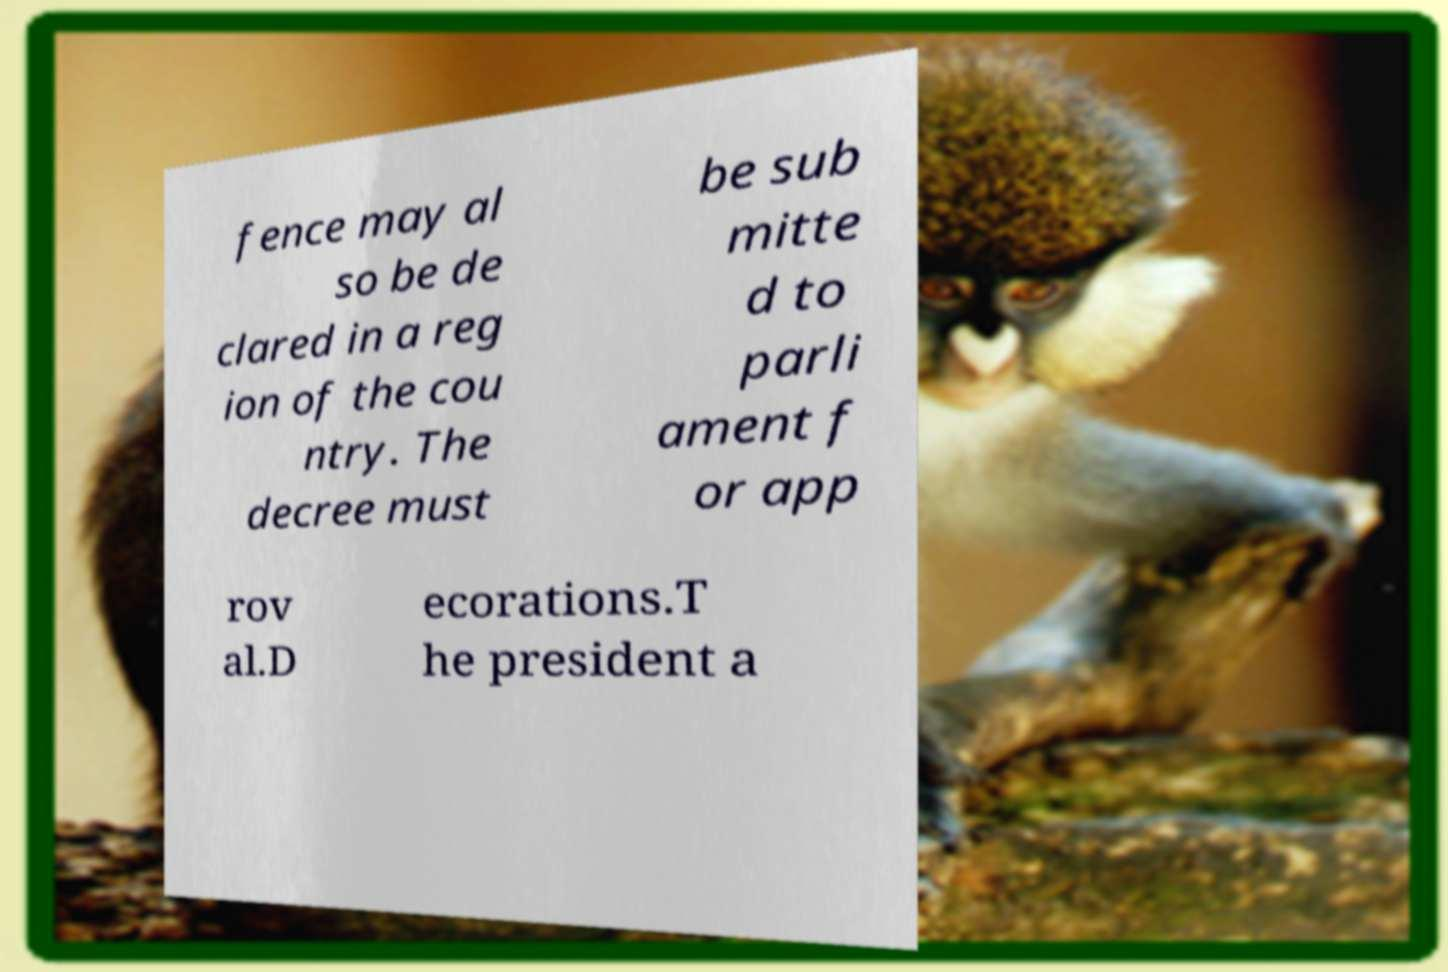Can you read and provide the text displayed in the image?This photo seems to have some interesting text. Can you extract and type it out for me? fence may al so be de clared in a reg ion of the cou ntry. The decree must be sub mitte d to parli ament f or app rov al.D ecorations.T he president a 